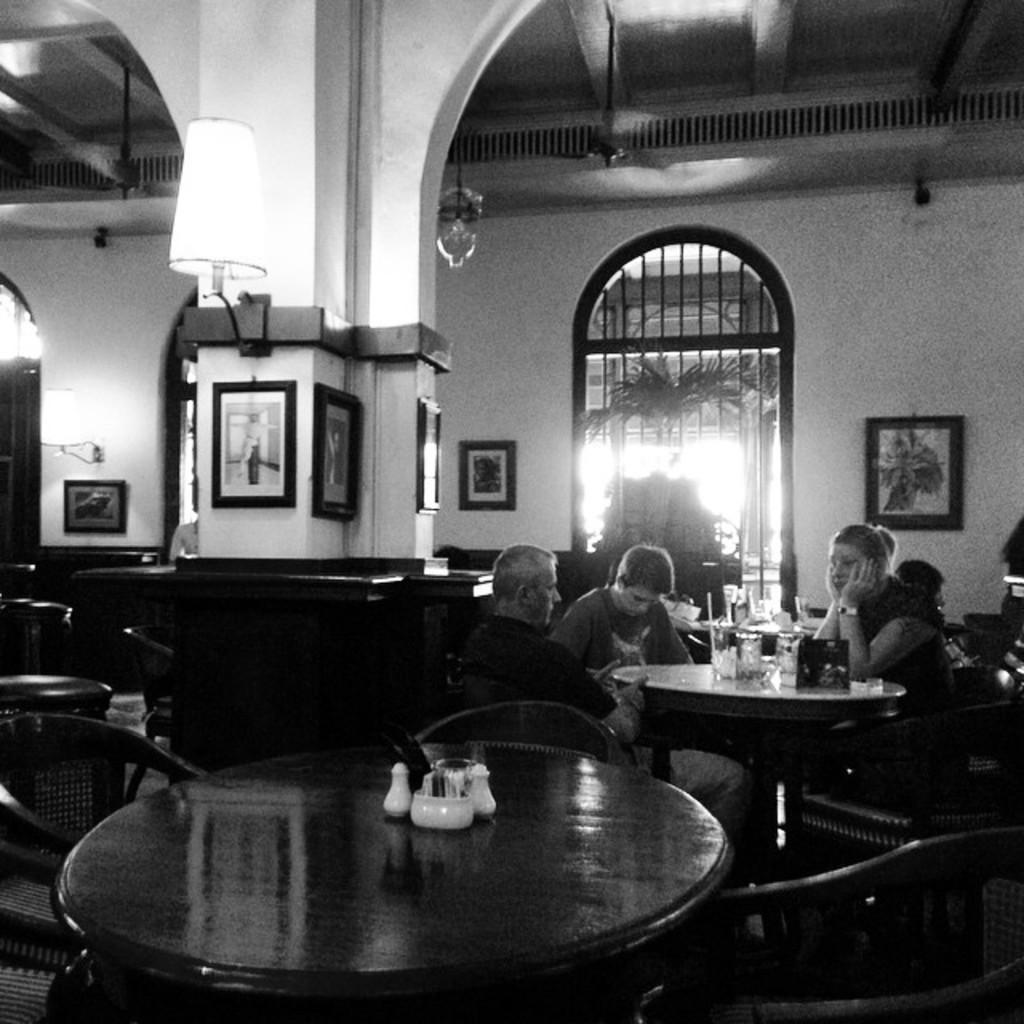In one or two sentences, can you explain what this image depicts? In this picture there are a group of people sitting and among them the woman is staring at the person in front of her. 